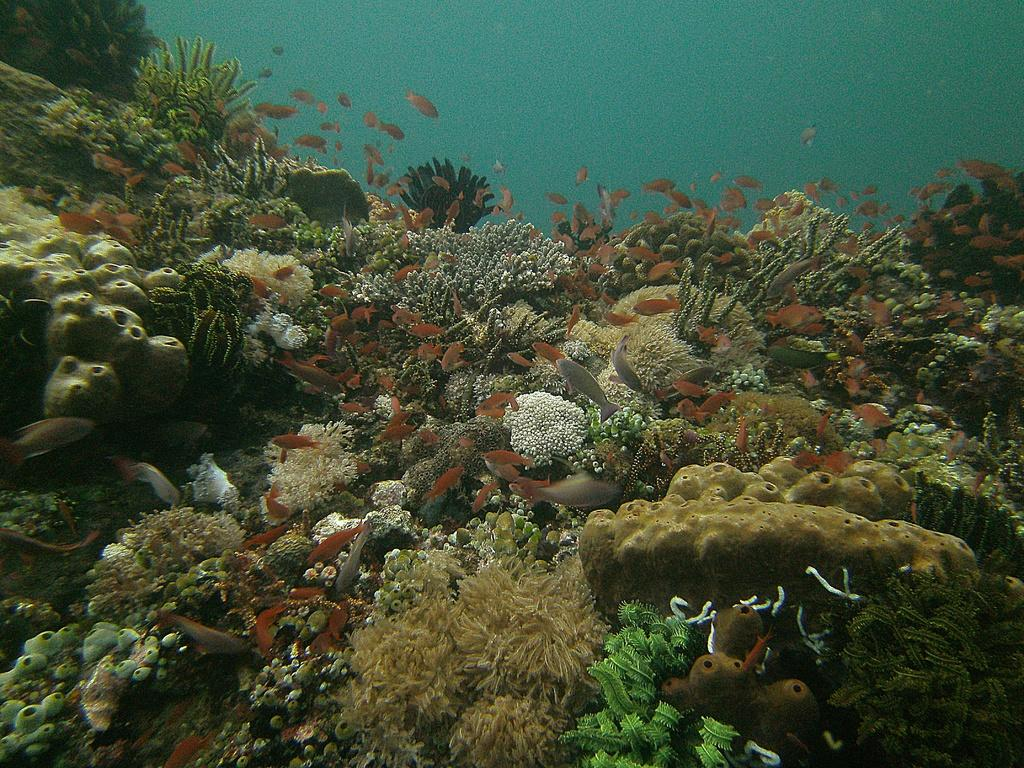What type of animals can be seen in the image? There are fishes and sea animals in the image. What other objects or features can be seen in the image? There are corals in the image. Can you describe the environment in which the animals and corals are located? The image depicts an underwater environment. What type of harmony can be heard in the image? There is no sound or music present in the image, so it is not possible to determine the type of harmony. 